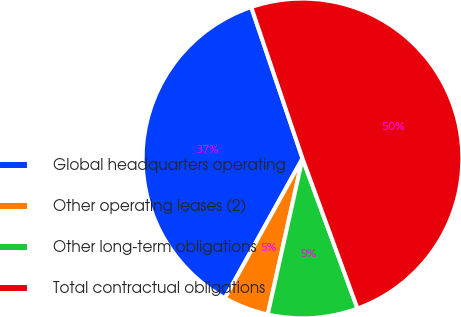<chart> <loc_0><loc_0><loc_500><loc_500><pie_chart><fcel>Global headquarters operating<fcel>Other operating leases (2)<fcel>Other long-term obligations<fcel>Total contractual obligations<nl><fcel>36.73%<fcel>4.58%<fcel>9.08%<fcel>49.61%<nl></chart> 